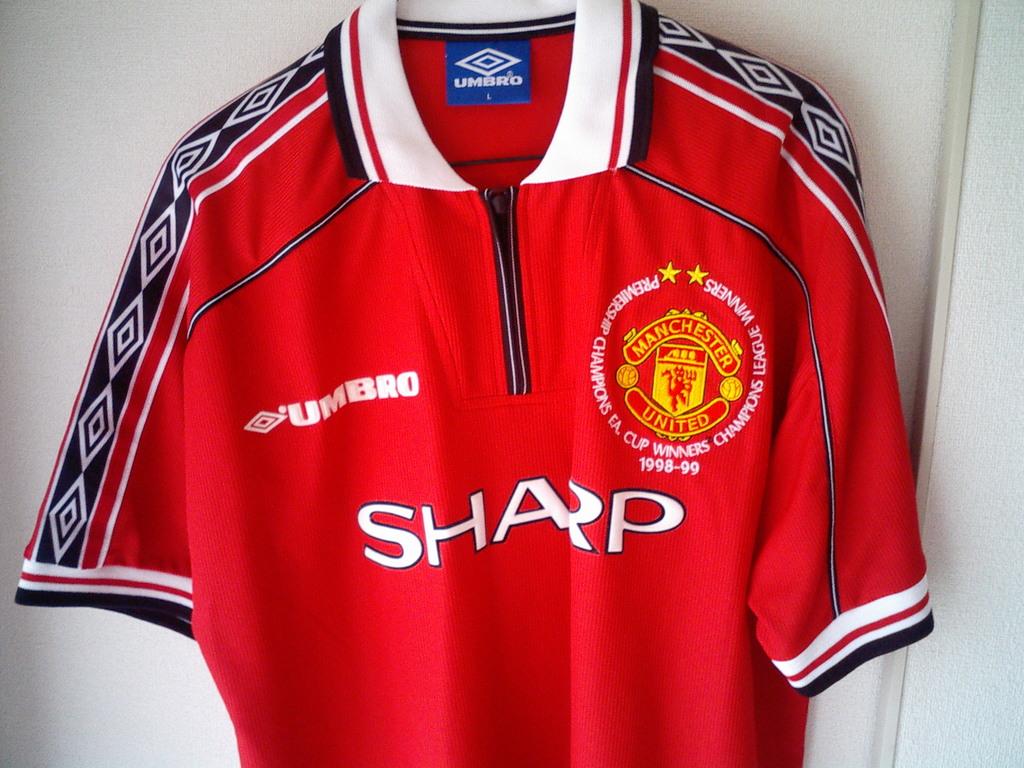What is the brand name of this shirt?
Your response must be concise. Umbro. What club is represented on the shirt?
Your response must be concise. Manchester united. 